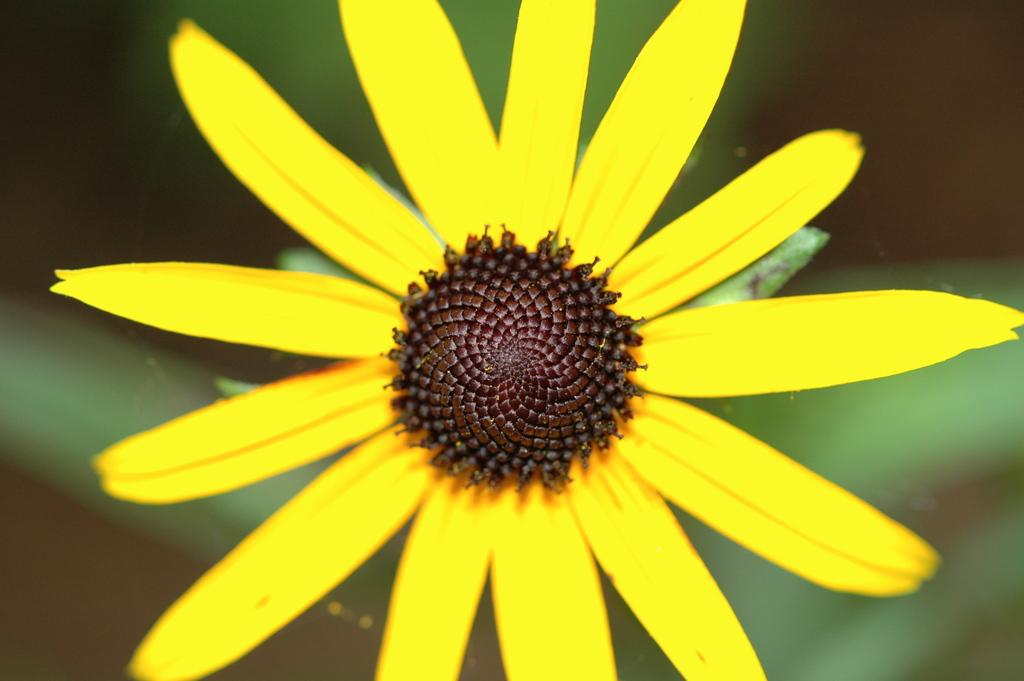What is the main subject in the foreground of the image? There is a yellow flower in the foreground of the image. What can be observed about the background of the image? The background of the image is blurred. What type of pump is visible in the image? There is no pump present in the image; it features a yellow flower in the foreground and a blurred background. 